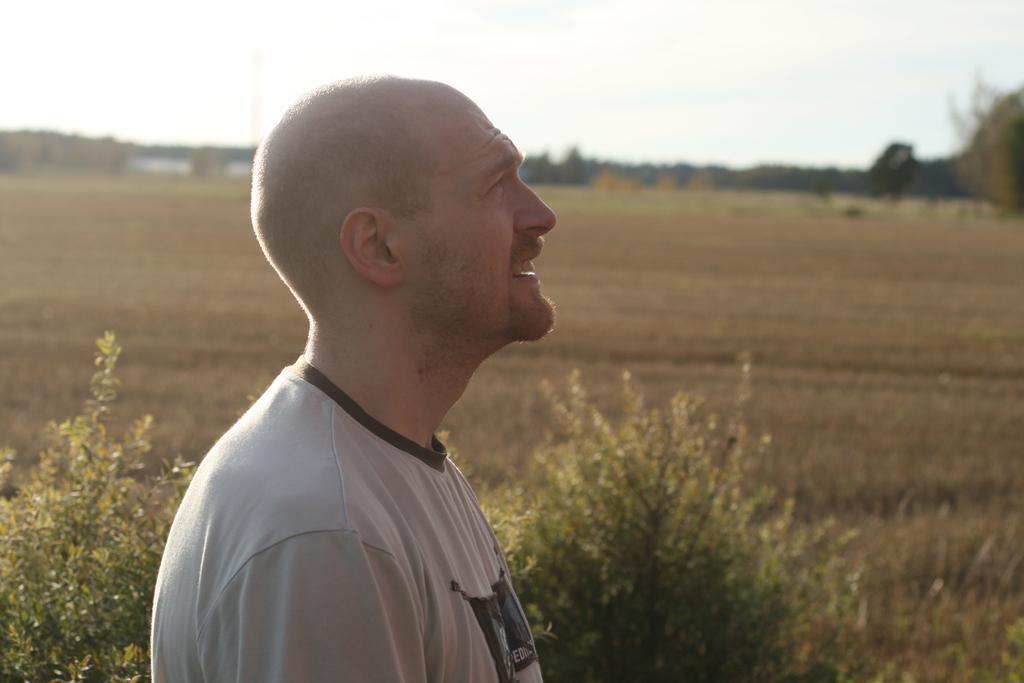Can you describe this image briefly? In the foreground of the image we can see a person wearing white color T-shirt is standing here. The background of the image is slightly blurred, where we can see the plants, trees, ground and the sky in the background. 